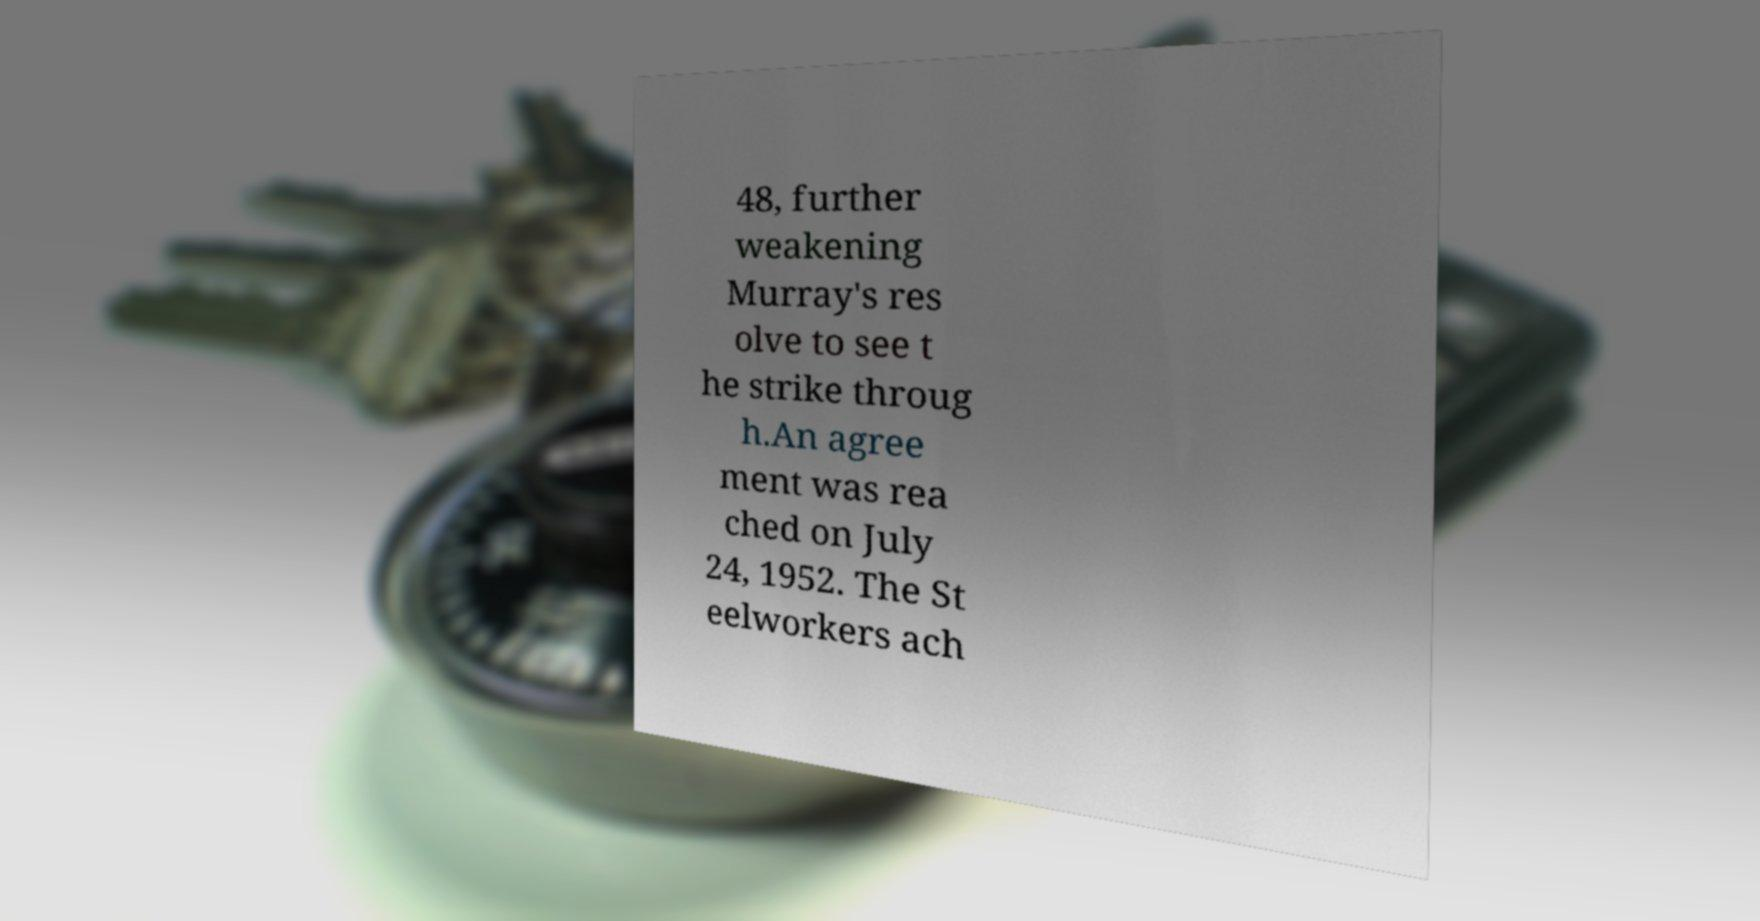Please identify and transcribe the text found in this image. 48, further weakening Murray's res olve to see t he strike throug h.An agree ment was rea ched on July 24, 1952. The St eelworkers ach 